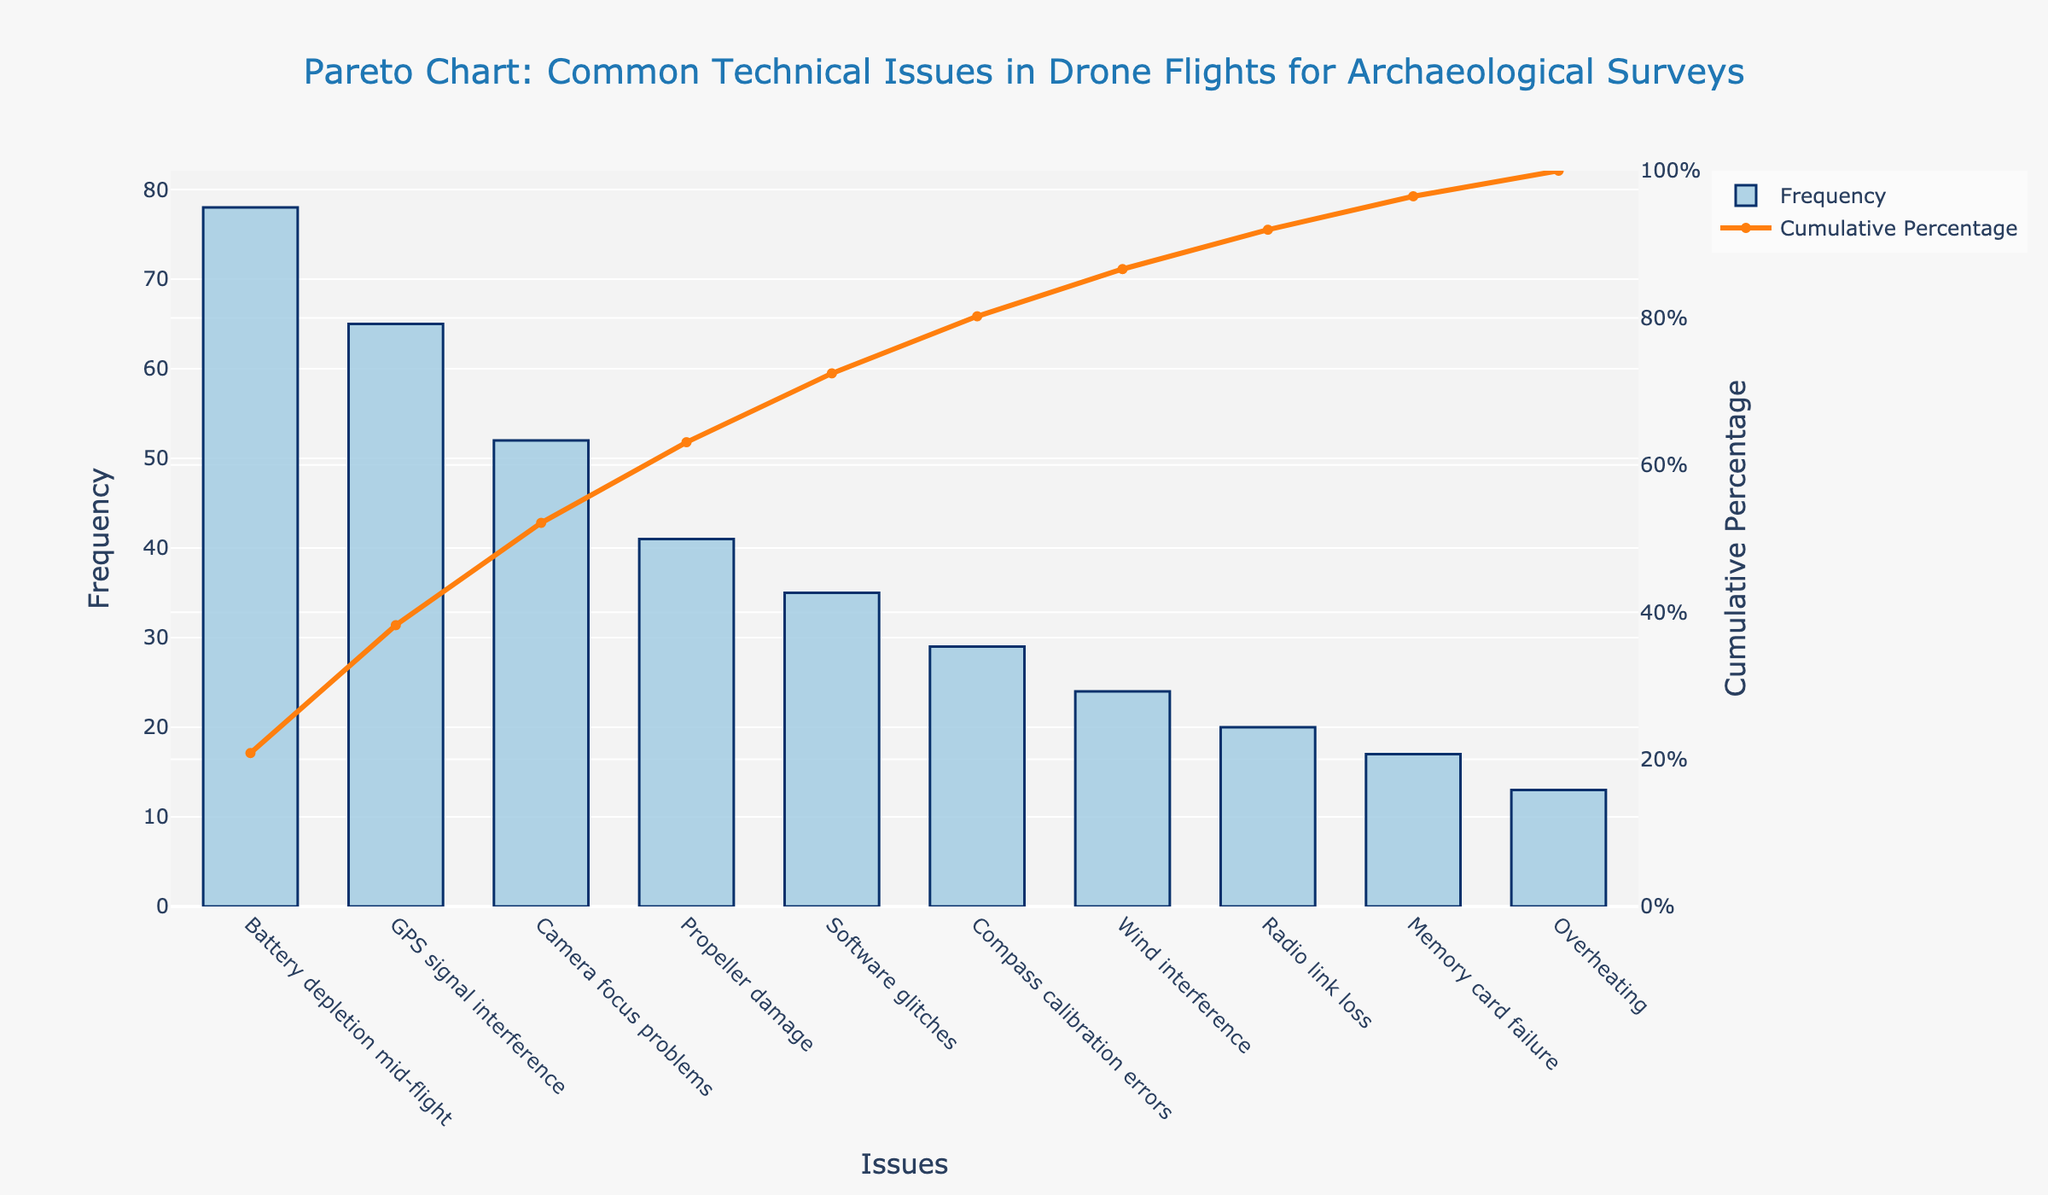What is the most common technical issue encountered during drone flights? The most common issue is identified by the bar with the highest frequency on the left.
Answer: Battery depletion mid-flight Which issue has the lowest frequency? The issue with the lowest bar height on the right indicates the least common problem.
Answer: Overheating What percentage of technical issues does "Battery depletion mid-flight" and "GPS signal interference" together account for? Sum the frequencies of both issues, calculate this as a percentage of the total number of issues, then sum their cumulative percentages. The total frequency is 78 + 65 = 143 issues. The cumulative frequency after "GPS signal interference" is 78 (Battery) + 65 = 143, and 143 / 374 * 100 = 38.2%.
Answer: 38.2% What is the cumulative percentage after "Propeller damage"? Locate the cumulative percentage value on the line graph above "Propeller damage."
Answer: 62.0% Which issue represents approximately the 80th percentile in cumulative percentage terms? Find the issue where the cumulative percentage line crosses around 80%. "Memory card failure" ends just over 80%, as it sums with 13% of "Overheating".
Answer: Memory card failure How many issues need to be resolved to address 90% of all problems? Identify the point on the line graph where the cumulative percentage reaches 90%. The required number of issues includes 'Memory card failure' and any issue before it.
Answer: 8 issues Which issue has a frequency closest to 50% of that of "Battery depletion mid-flight"? Calculate 50% of the frequency for "Battery depletion mid-flight" (78 * 0.5 = 39) and find the issue closest to this value.
Answer: Propeller damage What is the total number of technical issues recorded? Sum all frequencies. The total accumulative frequencies equal the height of 'Overheating'.
Answer: 374 Does fixing the top three issues reduce the cumulative percentage below half of all problems? Look at the cumulative percentage after "Camera focus problems." It sums up to 195 / 374 * 100 = 52.14%.
Answer: No Which issues constitute less than 10% of the total problems individually? Find the issues with less than 10% frequency each concerning total problems (17 or less).
Answer: Compass calibration errors, Wind interference, Radio link loss, Memory card failure, Overheating 